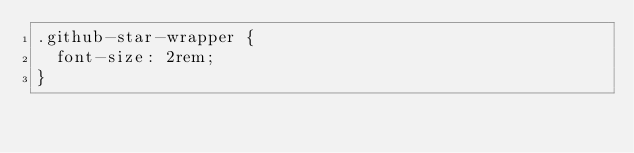Convert code to text. <code><loc_0><loc_0><loc_500><loc_500><_CSS_>.github-star-wrapper {
  font-size: 2rem;
}
</code> 